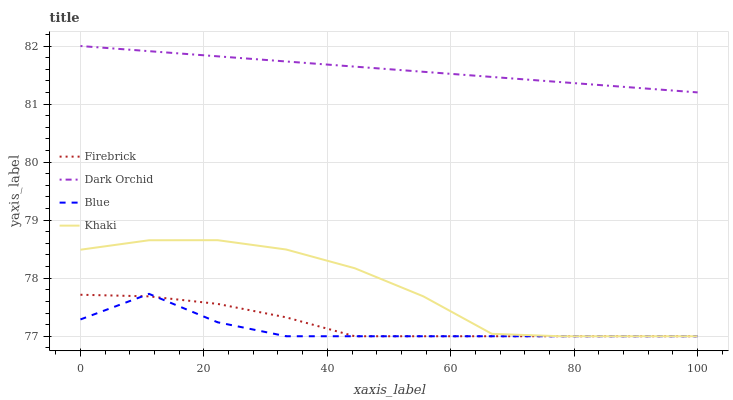Does Blue have the minimum area under the curve?
Answer yes or no. Yes. Does Dark Orchid have the maximum area under the curve?
Answer yes or no. Yes. Does Firebrick have the minimum area under the curve?
Answer yes or no. No. Does Firebrick have the maximum area under the curve?
Answer yes or no. No. Is Dark Orchid the smoothest?
Answer yes or no. Yes. Is Khaki the roughest?
Answer yes or no. Yes. Is Firebrick the smoothest?
Answer yes or no. No. Is Firebrick the roughest?
Answer yes or no. No. Does Dark Orchid have the lowest value?
Answer yes or no. No. Does Dark Orchid have the highest value?
Answer yes or no. Yes. Does Khaki have the highest value?
Answer yes or no. No. Is Firebrick less than Dark Orchid?
Answer yes or no. Yes. Is Dark Orchid greater than Khaki?
Answer yes or no. Yes. Does Firebrick intersect Dark Orchid?
Answer yes or no. No. 